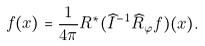Convert formula to latex. <formula><loc_0><loc_0><loc_500><loc_500>f ( x ) = \frac { 1 } { 4 \pi } R ^ { * } ( \widehat { I } ^ { - 1 } \widehat { R } _ { \varphi } f ) ( x ) .</formula> 